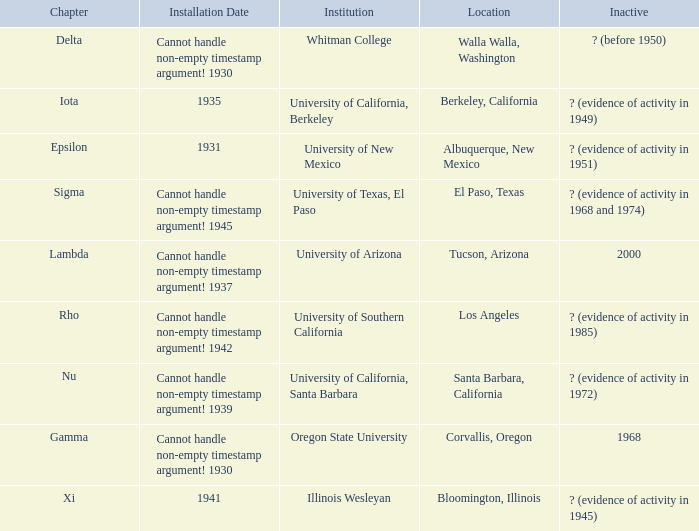What does the inactive state for University of Texas, El Paso?  ? (evidence of activity in 1968 and 1974). 